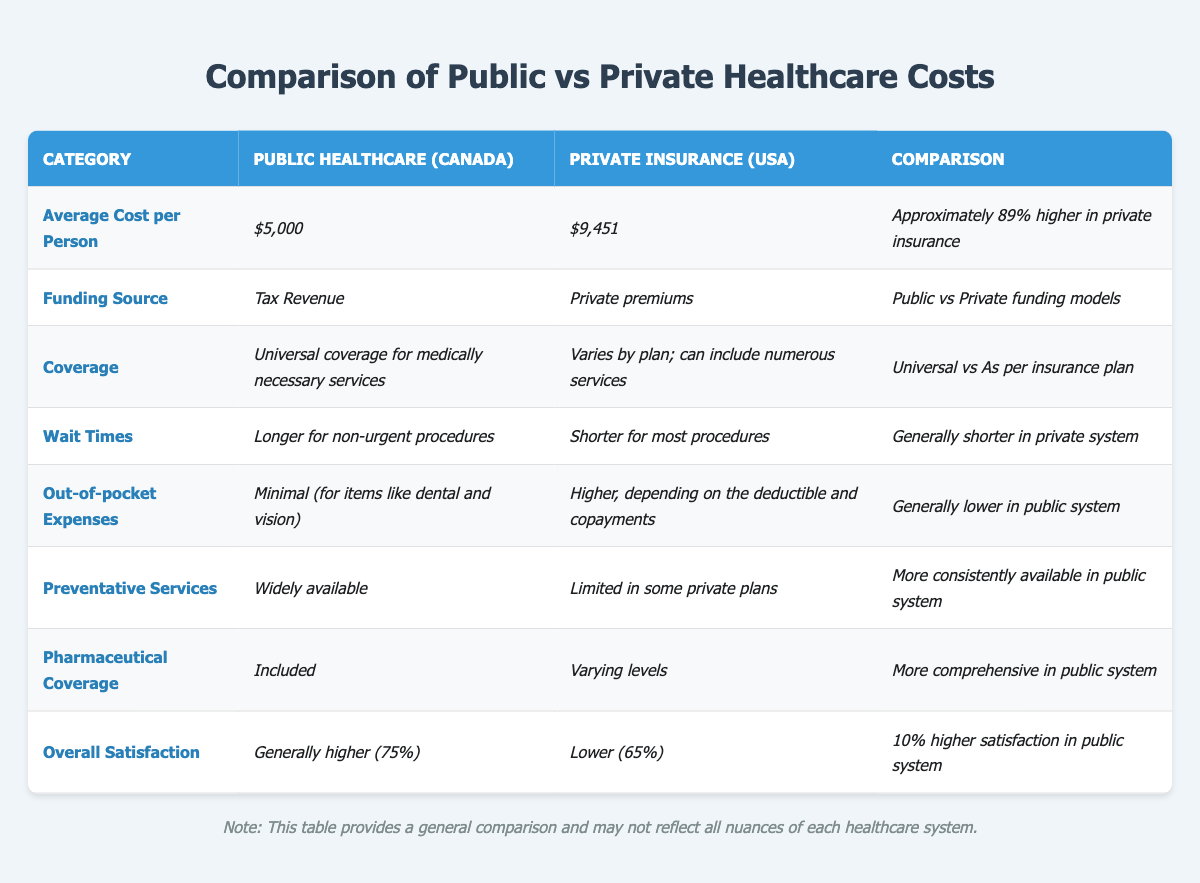What is the average cost per person for public healthcare in Canada? The table specifies that the average cost per person for public healthcare in Canada is $5,000.
Answer: $5,000 What is the funding source for private insurance in the USA? According to the table, private insurance funding comes from private premiums.
Answer: Private premiums Is pharmaceutical coverage included in public healthcare in Canada? The table indicates that pharmaceutical coverage is included in public healthcare.
Answer: Yes How much higher is the average cost per person for private insurance compared to public healthcare? The average cost per person for private insurance is $9,451 and for public healthcare, it is $5,000. The difference is $9,451 - $5,000 = $4,451, which is approximately 89% higher.
Answer: 89% higher Do public healthcare wait times tend to be shorter or longer for non-urgent procedures compared to private insurance? The table states that public healthcare has longer wait times for non-urgent procedures, while private insurance has shorter wait times.
Answer: Longer What percentage of people are generally satisfied with public healthcare in Canada? The table shows that 75% of individuals are generally satisfied with public healthcare in Canada.
Answer: 75% In terms of coverage, how does public healthcare compare to private insurance? Public healthcare offers universal coverage for medically necessary services, while private insurance coverage varies by plan.
Answer: Universal vs. varies by plan What can be deduced about the out-of-pocket expenses between the two systems? The table shows that out-of-pocket expenses are minimal in public healthcare, while they are higher in private insurance due to deductibles and copayments.
Answer: Minimal in public, higher in private If someone is looking for preventative services, which healthcare system provides them more consistently? The table indicates that preventative services are widely available in public healthcare, whereas they are limited in some private plans.
Answer: Public healthcare Is there a significant difference in overall satisfaction between the two systems? Yes, overall satisfaction is higher in public healthcare (75%) compared to private insurance (65%), showing a 10% difference.
Answer: Yes 